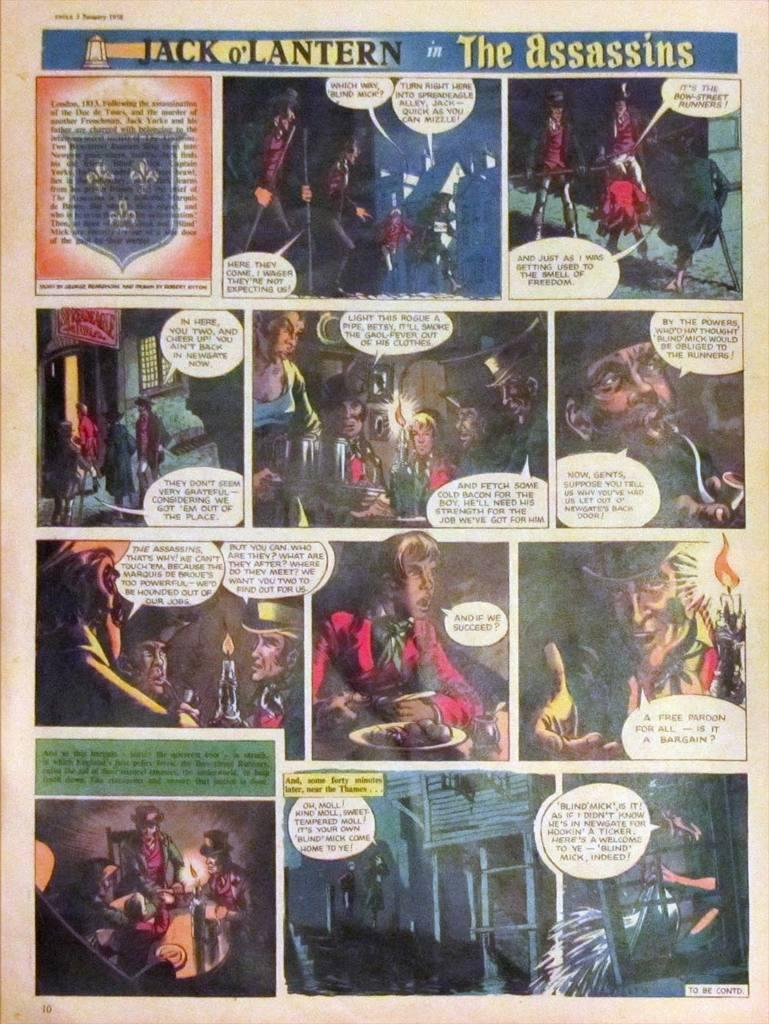<image>
Summarize the visual content of the image. A page from a comic that is titled JACK O'LANTERN in The Assassins. 